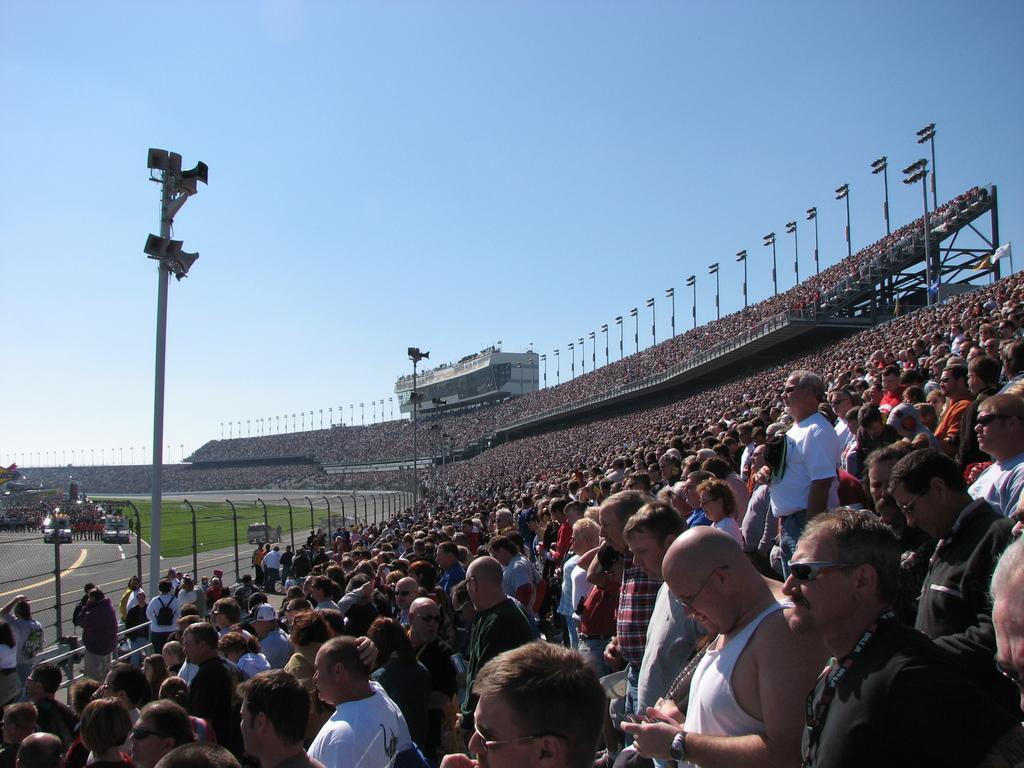Could you give a brief overview of what you see in this image? In the picture we can see a public sitting in the stadium in the chairs and near to them, we can see a pole with lights and a grass surface and road with some show of cars and some people walking on it and in the background we can see some building and a sky. 